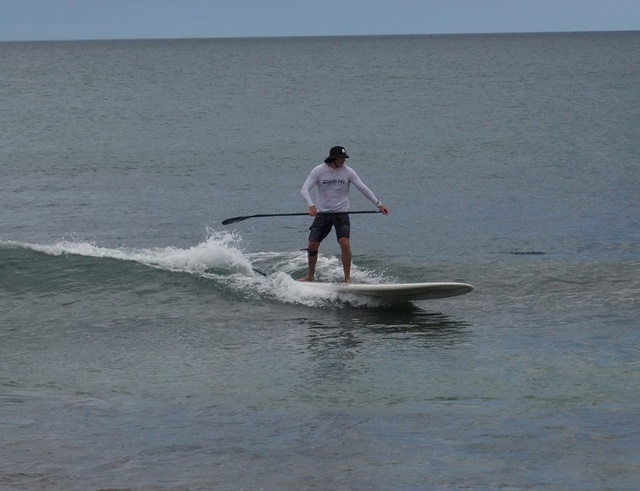Describe the objects in this image and their specific colors. I can see people in gray and black tones and surfboard in gray, black, darkgray, and lightgray tones in this image. 